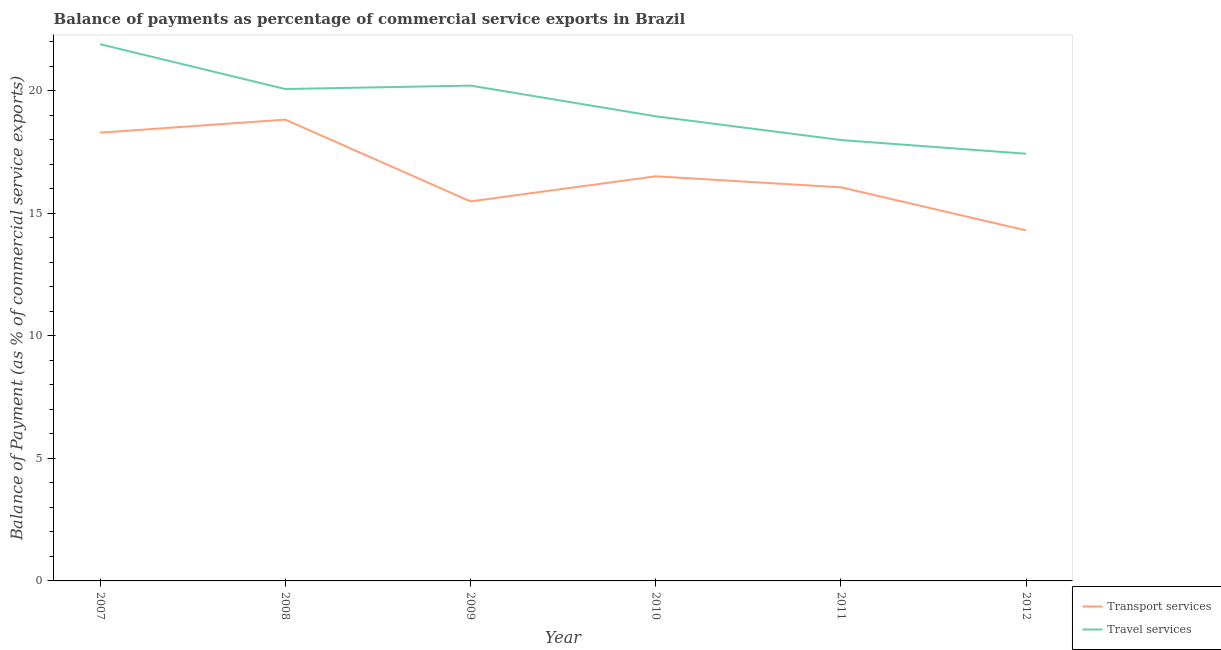Is the number of lines equal to the number of legend labels?
Provide a short and direct response. Yes. What is the balance of payments of transport services in 2011?
Your answer should be compact. 16.06. Across all years, what is the maximum balance of payments of transport services?
Provide a short and direct response. 18.82. Across all years, what is the minimum balance of payments of transport services?
Provide a short and direct response. 14.3. In which year was the balance of payments of transport services maximum?
Keep it short and to the point. 2008. What is the total balance of payments of travel services in the graph?
Provide a short and direct response. 116.57. What is the difference between the balance of payments of transport services in 2007 and that in 2010?
Offer a very short reply. 1.78. What is the difference between the balance of payments of transport services in 2012 and the balance of payments of travel services in 2007?
Offer a terse response. -7.6. What is the average balance of payments of transport services per year?
Your response must be concise. 16.58. In the year 2012, what is the difference between the balance of payments of travel services and balance of payments of transport services?
Make the answer very short. 3.13. What is the ratio of the balance of payments of travel services in 2010 to that in 2012?
Your answer should be compact. 1.09. Is the balance of payments of transport services in 2008 less than that in 2011?
Make the answer very short. No. What is the difference between the highest and the second highest balance of payments of transport services?
Offer a very short reply. 0.53. What is the difference between the highest and the lowest balance of payments of transport services?
Your response must be concise. 4.52. In how many years, is the balance of payments of transport services greater than the average balance of payments of transport services taken over all years?
Make the answer very short. 2. Does the balance of payments of transport services monotonically increase over the years?
Make the answer very short. No. Is the balance of payments of transport services strictly greater than the balance of payments of travel services over the years?
Ensure brevity in your answer.  No. Is the balance of payments of travel services strictly less than the balance of payments of transport services over the years?
Provide a succinct answer. No. How many lines are there?
Offer a very short reply. 2. What is the difference between two consecutive major ticks on the Y-axis?
Offer a terse response. 5. Are the values on the major ticks of Y-axis written in scientific E-notation?
Your answer should be compact. No. Does the graph contain any zero values?
Provide a succinct answer. No. What is the title of the graph?
Offer a very short reply. Balance of payments as percentage of commercial service exports in Brazil. What is the label or title of the X-axis?
Your answer should be compact. Year. What is the label or title of the Y-axis?
Your response must be concise. Balance of Payment (as % of commercial service exports). What is the Balance of Payment (as % of commercial service exports) in Transport services in 2007?
Keep it short and to the point. 18.29. What is the Balance of Payment (as % of commercial service exports) in Travel services in 2007?
Offer a terse response. 21.9. What is the Balance of Payment (as % of commercial service exports) in Transport services in 2008?
Make the answer very short. 18.82. What is the Balance of Payment (as % of commercial service exports) in Travel services in 2008?
Make the answer very short. 20.07. What is the Balance of Payment (as % of commercial service exports) of Transport services in 2009?
Your answer should be compact. 15.49. What is the Balance of Payment (as % of commercial service exports) of Travel services in 2009?
Make the answer very short. 20.21. What is the Balance of Payment (as % of commercial service exports) of Transport services in 2010?
Provide a short and direct response. 16.51. What is the Balance of Payment (as % of commercial service exports) of Travel services in 2010?
Your response must be concise. 18.96. What is the Balance of Payment (as % of commercial service exports) of Transport services in 2011?
Your response must be concise. 16.06. What is the Balance of Payment (as % of commercial service exports) in Travel services in 2011?
Keep it short and to the point. 17.99. What is the Balance of Payment (as % of commercial service exports) of Transport services in 2012?
Give a very brief answer. 14.3. What is the Balance of Payment (as % of commercial service exports) of Travel services in 2012?
Ensure brevity in your answer.  17.43. Across all years, what is the maximum Balance of Payment (as % of commercial service exports) of Transport services?
Your answer should be compact. 18.82. Across all years, what is the maximum Balance of Payment (as % of commercial service exports) of Travel services?
Give a very brief answer. 21.9. Across all years, what is the minimum Balance of Payment (as % of commercial service exports) in Transport services?
Your answer should be compact. 14.3. Across all years, what is the minimum Balance of Payment (as % of commercial service exports) of Travel services?
Provide a short and direct response. 17.43. What is the total Balance of Payment (as % of commercial service exports) in Transport services in the graph?
Offer a very short reply. 99.47. What is the total Balance of Payment (as % of commercial service exports) in Travel services in the graph?
Offer a very short reply. 116.57. What is the difference between the Balance of Payment (as % of commercial service exports) of Transport services in 2007 and that in 2008?
Keep it short and to the point. -0.53. What is the difference between the Balance of Payment (as % of commercial service exports) in Travel services in 2007 and that in 2008?
Give a very brief answer. 1.83. What is the difference between the Balance of Payment (as % of commercial service exports) of Transport services in 2007 and that in 2009?
Offer a terse response. 2.8. What is the difference between the Balance of Payment (as % of commercial service exports) of Travel services in 2007 and that in 2009?
Your response must be concise. 1.69. What is the difference between the Balance of Payment (as % of commercial service exports) of Transport services in 2007 and that in 2010?
Provide a short and direct response. 1.78. What is the difference between the Balance of Payment (as % of commercial service exports) in Travel services in 2007 and that in 2010?
Your response must be concise. 2.94. What is the difference between the Balance of Payment (as % of commercial service exports) of Transport services in 2007 and that in 2011?
Ensure brevity in your answer.  2.23. What is the difference between the Balance of Payment (as % of commercial service exports) of Travel services in 2007 and that in 2011?
Offer a terse response. 3.91. What is the difference between the Balance of Payment (as % of commercial service exports) of Transport services in 2007 and that in 2012?
Keep it short and to the point. 3.99. What is the difference between the Balance of Payment (as % of commercial service exports) in Travel services in 2007 and that in 2012?
Make the answer very short. 4.47. What is the difference between the Balance of Payment (as % of commercial service exports) in Transport services in 2008 and that in 2009?
Offer a terse response. 3.34. What is the difference between the Balance of Payment (as % of commercial service exports) of Travel services in 2008 and that in 2009?
Ensure brevity in your answer.  -0.14. What is the difference between the Balance of Payment (as % of commercial service exports) of Transport services in 2008 and that in 2010?
Make the answer very short. 2.31. What is the difference between the Balance of Payment (as % of commercial service exports) of Travel services in 2008 and that in 2010?
Provide a short and direct response. 1.11. What is the difference between the Balance of Payment (as % of commercial service exports) in Transport services in 2008 and that in 2011?
Your answer should be compact. 2.76. What is the difference between the Balance of Payment (as % of commercial service exports) in Travel services in 2008 and that in 2011?
Make the answer very short. 2.08. What is the difference between the Balance of Payment (as % of commercial service exports) in Transport services in 2008 and that in 2012?
Provide a succinct answer. 4.52. What is the difference between the Balance of Payment (as % of commercial service exports) in Travel services in 2008 and that in 2012?
Your answer should be very brief. 2.64. What is the difference between the Balance of Payment (as % of commercial service exports) in Transport services in 2009 and that in 2010?
Your answer should be very brief. -1.02. What is the difference between the Balance of Payment (as % of commercial service exports) of Travel services in 2009 and that in 2010?
Offer a terse response. 1.25. What is the difference between the Balance of Payment (as % of commercial service exports) in Transport services in 2009 and that in 2011?
Your answer should be very brief. -0.57. What is the difference between the Balance of Payment (as % of commercial service exports) of Travel services in 2009 and that in 2011?
Your answer should be compact. 2.22. What is the difference between the Balance of Payment (as % of commercial service exports) in Transport services in 2009 and that in 2012?
Provide a succinct answer. 1.19. What is the difference between the Balance of Payment (as % of commercial service exports) in Travel services in 2009 and that in 2012?
Offer a terse response. 2.78. What is the difference between the Balance of Payment (as % of commercial service exports) of Transport services in 2010 and that in 2011?
Make the answer very short. 0.45. What is the difference between the Balance of Payment (as % of commercial service exports) in Travel services in 2010 and that in 2011?
Provide a succinct answer. 0.97. What is the difference between the Balance of Payment (as % of commercial service exports) of Transport services in 2010 and that in 2012?
Your answer should be very brief. 2.21. What is the difference between the Balance of Payment (as % of commercial service exports) of Travel services in 2010 and that in 2012?
Make the answer very short. 1.53. What is the difference between the Balance of Payment (as % of commercial service exports) in Transport services in 2011 and that in 2012?
Provide a succinct answer. 1.76. What is the difference between the Balance of Payment (as % of commercial service exports) of Travel services in 2011 and that in 2012?
Your answer should be compact. 0.56. What is the difference between the Balance of Payment (as % of commercial service exports) of Transport services in 2007 and the Balance of Payment (as % of commercial service exports) of Travel services in 2008?
Offer a very short reply. -1.78. What is the difference between the Balance of Payment (as % of commercial service exports) of Transport services in 2007 and the Balance of Payment (as % of commercial service exports) of Travel services in 2009?
Give a very brief answer. -1.92. What is the difference between the Balance of Payment (as % of commercial service exports) in Transport services in 2007 and the Balance of Payment (as % of commercial service exports) in Travel services in 2010?
Give a very brief answer. -0.67. What is the difference between the Balance of Payment (as % of commercial service exports) in Transport services in 2007 and the Balance of Payment (as % of commercial service exports) in Travel services in 2011?
Keep it short and to the point. 0.3. What is the difference between the Balance of Payment (as % of commercial service exports) in Transport services in 2007 and the Balance of Payment (as % of commercial service exports) in Travel services in 2012?
Offer a terse response. 0.86. What is the difference between the Balance of Payment (as % of commercial service exports) of Transport services in 2008 and the Balance of Payment (as % of commercial service exports) of Travel services in 2009?
Give a very brief answer. -1.39. What is the difference between the Balance of Payment (as % of commercial service exports) of Transport services in 2008 and the Balance of Payment (as % of commercial service exports) of Travel services in 2010?
Offer a very short reply. -0.14. What is the difference between the Balance of Payment (as % of commercial service exports) of Transport services in 2008 and the Balance of Payment (as % of commercial service exports) of Travel services in 2011?
Offer a very short reply. 0.83. What is the difference between the Balance of Payment (as % of commercial service exports) of Transport services in 2008 and the Balance of Payment (as % of commercial service exports) of Travel services in 2012?
Ensure brevity in your answer.  1.39. What is the difference between the Balance of Payment (as % of commercial service exports) of Transport services in 2009 and the Balance of Payment (as % of commercial service exports) of Travel services in 2010?
Offer a very short reply. -3.47. What is the difference between the Balance of Payment (as % of commercial service exports) of Transport services in 2009 and the Balance of Payment (as % of commercial service exports) of Travel services in 2011?
Provide a succinct answer. -2.5. What is the difference between the Balance of Payment (as % of commercial service exports) in Transport services in 2009 and the Balance of Payment (as % of commercial service exports) in Travel services in 2012?
Provide a succinct answer. -1.94. What is the difference between the Balance of Payment (as % of commercial service exports) of Transport services in 2010 and the Balance of Payment (as % of commercial service exports) of Travel services in 2011?
Give a very brief answer. -1.48. What is the difference between the Balance of Payment (as % of commercial service exports) of Transport services in 2010 and the Balance of Payment (as % of commercial service exports) of Travel services in 2012?
Offer a very short reply. -0.92. What is the difference between the Balance of Payment (as % of commercial service exports) in Transport services in 2011 and the Balance of Payment (as % of commercial service exports) in Travel services in 2012?
Offer a terse response. -1.37. What is the average Balance of Payment (as % of commercial service exports) of Transport services per year?
Provide a short and direct response. 16.58. What is the average Balance of Payment (as % of commercial service exports) of Travel services per year?
Provide a succinct answer. 19.43. In the year 2007, what is the difference between the Balance of Payment (as % of commercial service exports) of Transport services and Balance of Payment (as % of commercial service exports) of Travel services?
Offer a terse response. -3.61. In the year 2008, what is the difference between the Balance of Payment (as % of commercial service exports) of Transport services and Balance of Payment (as % of commercial service exports) of Travel services?
Offer a terse response. -1.25. In the year 2009, what is the difference between the Balance of Payment (as % of commercial service exports) of Transport services and Balance of Payment (as % of commercial service exports) of Travel services?
Ensure brevity in your answer.  -4.72. In the year 2010, what is the difference between the Balance of Payment (as % of commercial service exports) in Transport services and Balance of Payment (as % of commercial service exports) in Travel services?
Give a very brief answer. -2.45. In the year 2011, what is the difference between the Balance of Payment (as % of commercial service exports) in Transport services and Balance of Payment (as % of commercial service exports) in Travel services?
Keep it short and to the point. -1.93. In the year 2012, what is the difference between the Balance of Payment (as % of commercial service exports) of Transport services and Balance of Payment (as % of commercial service exports) of Travel services?
Keep it short and to the point. -3.13. What is the ratio of the Balance of Payment (as % of commercial service exports) in Transport services in 2007 to that in 2008?
Provide a succinct answer. 0.97. What is the ratio of the Balance of Payment (as % of commercial service exports) in Travel services in 2007 to that in 2008?
Offer a terse response. 1.09. What is the ratio of the Balance of Payment (as % of commercial service exports) of Transport services in 2007 to that in 2009?
Provide a short and direct response. 1.18. What is the ratio of the Balance of Payment (as % of commercial service exports) of Travel services in 2007 to that in 2009?
Your response must be concise. 1.08. What is the ratio of the Balance of Payment (as % of commercial service exports) in Transport services in 2007 to that in 2010?
Provide a succinct answer. 1.11. What is the ratio of the Balance of Payment (as % of commercial service exports) in Travel services in 2007 to that in 2010?
Your answer should be compact. 1.16. What is the ratio of the Balance of Payment (as % of commercial service exports) in Transport services in 2007 to that in 2011?
Give a very brief answer. 1.14. What is the ratio of the Balance of Payment (as % of commercial service exports) of Travel services in 2007 to that in 2011?
Ensure brevity in your answer.  1.22. What is the ratio of the Balance of Payment (as % of commercial service exports) of Transport services in 2007 to that in 2012?
Give a very brief answer. 1.28. What is the ratio of the Balance of Payment (as % of commercial service exports) in Travel services in 2007 to that in 2012?
Your answer should be very brief. 1.26. What is the ratio of the Balance of Payment (as % of commercial service exports) of Transport services in 2008 to that in 2009?
Your answer should be very brief. 1.22. What is the ratio of the Balance of Payment (as % of commercial service exports) of Travel services in 2008 to that in 2009?
Offer a terse response. 0.99. What is the ratio of the Balance of Payment (as % of commercial service exports) of Transport services in 2008 to that in 2010?
Ensure brevity in your answer.  1.14. What is the ratio of the Balance of Payment (as % of commercial service exports) in Travel services in 2008 to that in 2010?
Keep it short and to the point. 1.06. What is the ratio of the Balance of Payment (as % of commercial service exports) of Transport services in 2008 to that in 2011?
Keep it short and to the point. 1.17. What is the ratio of the Balance of Payment (as % of commercial service exports) in Travel services in 2008 to that in 2011?
Your answer should be very brief. 1.12. What is the ratio of the Balance of Payment (as % of commercial service exports) of Transport services in 2008 to that in 2012?
Give a very brief answer. 1.32. What is the ratio of the Balance of Payment (as % of commercial service exports) of Travel services in 2008 to that in 2012?
Provide a succinct answer. 1.15. What is the ratio of the Balance of Payment (as % of commercial service exports) in Transport services in 2009 to that in 2010?
Ensure brevity in your answer.  0.94. What is the ratio of the Balance of Payment (as % of commercial service exports) in Travel services in 2009 to that in 2010?
Offer a very short reply. 1.07. What is the ratio of the Balance of Payment (as % of commercial service exports) in Travel services in 2009 to that in 2011?
Ensure brevity in your answer.  1.12. What is the ratio of the Balance of Payment (as % of commercial service exports) in Transport services in 2009 to that in 2012?
Your answer should be very brief. 1.08. What is the ratio of the Balance of Payment (as % of commercial service exports) of Travel services in 2009 to that in 2012?
Your answer should be very brief. 1.16. What is the ratio of the Balance of Payment (as % of commercial service exports) of Transport services in 2010 to that in 2011?
Provide a short and direct response. 1.03. What is the ratio of the Balance of Payment (as % of commercial service exports) of Travel services in 2010 to that in 2011?
Offer a terse response. 1.05. What is the ratio of the Balance of Payment (as % of commercial service exports) in Transport services in 2010 to that in 2012?
Your answer should be compact. 1.15. What is the ratio of the Balance of Payment (as % of commercial service exports) in Travel services in 2010 to that in 2012?
Ensure brevity in your answer.  1.09. What is the ratio of the Balance of Payment (as % of commercial service exports) of Transport services in 2011 to that in 2012?
Your answer should be compact. 1.12. What is the ratio of the Balance of Payment (as % of commercial service exports) of Travel services in 2011 to that in 2012?
Provide a succinct answer. 1.03. What is the difference between the highest and the second highest Balance of Payment (as % of commercial service exports) in Transport services?
Make the answer very short. 0.53. What is the difference between the highest and the second highest Balance of Payment (as % of commercial service exports) in Travel services?
Offer a terse response. 1.69. What is the difference between the highest and the lowest Balance of Payment (as % of commercial service exports) of Transport services?
Offer a very short reply. 4.52. What is the difference between the highest and the lowest Balance of Payment (as % of commercial service exports) of Travel services?
Give a very brief answer. 4.47. 